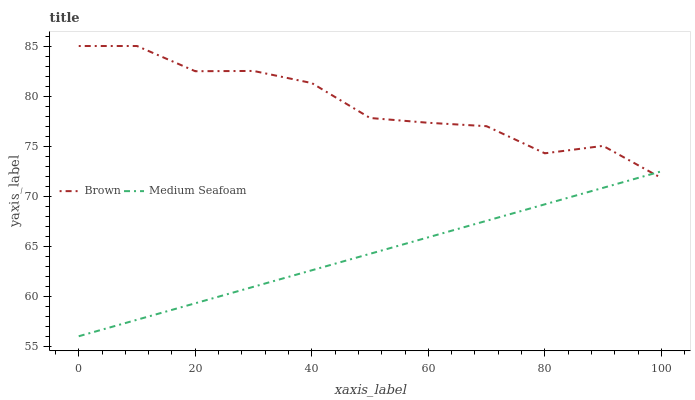Does Medium Seafoam have the minimum area under the curve?
Answer yes or no. Yes. Does Brown have the maximum area under the curve?
Answer yes or no. Yes. Does Medium Seafoam have the maximum area under the curve?
Answer yes or no. No. Is Medium Seafoam the smoothest?
Answer yes or no. Yes. Is Brown the roughest?
Answer yes or no. Yes. Is Medium Seafoam the roughest?
Answer yes or no. No. Does Medium Seafoam have the lowest value?
Answer yes or no. Yes. Does Brown have the highest value?
Answer yes or no. Yes. Does Medium Seafoam have the highest value?
Answer yes or no. No. Does Brown intersect Medium Seafoam?
Answer yes or no. Yes. Is Brown less than Medium Seafoam?
Answer yes or no. No. Is Brown greater than Medium Seafoam?
Answer yes or no. No. 